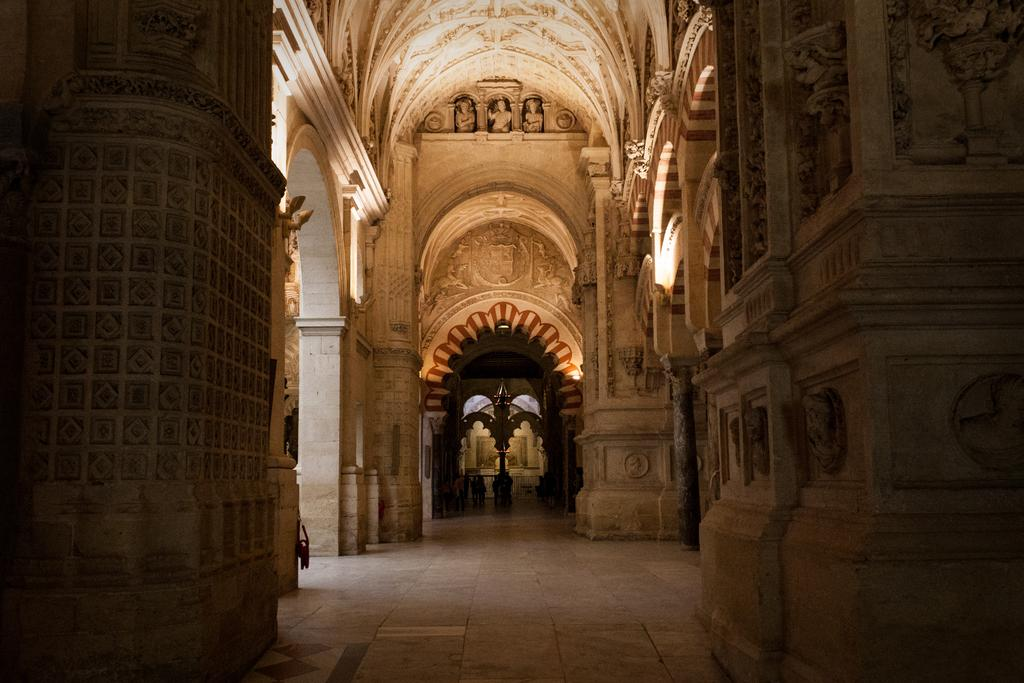What type of view does the image provide? The image shows an inner view of a building. Can you describe the lighting in the image? There is light visible in the image. What type of artwork can be seen on the walls in the image? There are sculptures on the walls in the image. Are there any sculptures on the ceiling in the image? Yes, there are sculptures on the ceiling in the image. What color is the lipstick on the curtain in the image? There is no lipstick or curtain present in the image. What type of paint is used on the sculptures in the image? The provided facts do not mention the type of paint used on the sculptures in the image. 